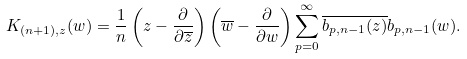<formula> <loc_0><loc_0><loc_500><loc_500>K _ { ( n + 1 ) , z } ( w ) = \frac { 1 } { n } \left ( z - \frac { \partial } { \partial \overline { z } } \right ) \left ( \overline { w } - \frac { \partial } { \partial w } \right ) \sum _ { p = 0 } ^ { \infty } \overline { b _ { p , n - 1 } ( z ) } b _ { p , n - 1 } ( w ) .</formula> 